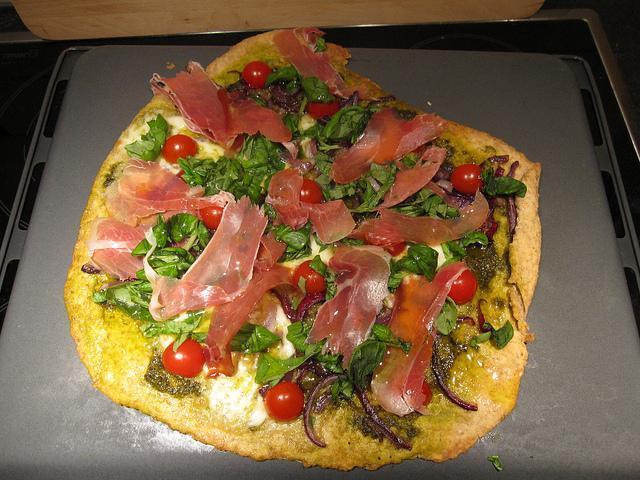Is "The pizza is in the oven." an appropriate description for the image?
Answer yes or no. No. Is the given caption "The pizza is inside the oven." fitting for the image?
Answer yes or no. No. 